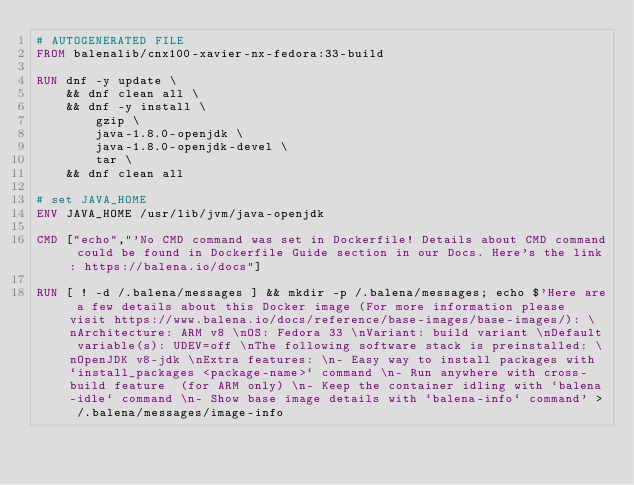Convert code to text. <code><loc_0><loc_0><loc_500><loc_500><_Dockerfile_># AUTOGENERATED FILE
FROM balenalib/cnx100-xavier-nx-fedora:33-build

RUN dnf -y update \
	&& dnf clean all \
	&& dnf -y install \
		gzip \
		java-1.8.0-openjdk \
		java-1.8.0-openjdk-devel \
		tar \
	&& dnf clean all

# set JAVA_HOME
ENV JAVA_HOME /usr/lib/jvm/java-openjdk

CMD ["echo","'No CMD command was set in Dockerfile! Details about CMD command could be found in Dockerfile Guide section in our Docs. Here's the link: https://balena.io/docs"]

RUN [ ! -d /.balena/messages ] && mkdir -p /.balena/messages; echo $'Here are a few details about this Docker image (For more information please visit https://www.balena.io/docs/reference/base-images/base-images/): \nArchitecture: ARM v8 \nOS: Fedora 33 \nVariant: build variant \nDefault variable(s): UDEV=off \nThe following software stack is preinstalled: \nOpenJDK v8-jdk \nExtra features: \n- Easy way to install packages with `install_packages <package-name>` command \n- Run anywhere with cross-build feature  (for ARM only) \n- Keep the container idling with `balena-idle` command \n- Show base image details with `balena-info` command' > /.balena/messages/image-info</code> 